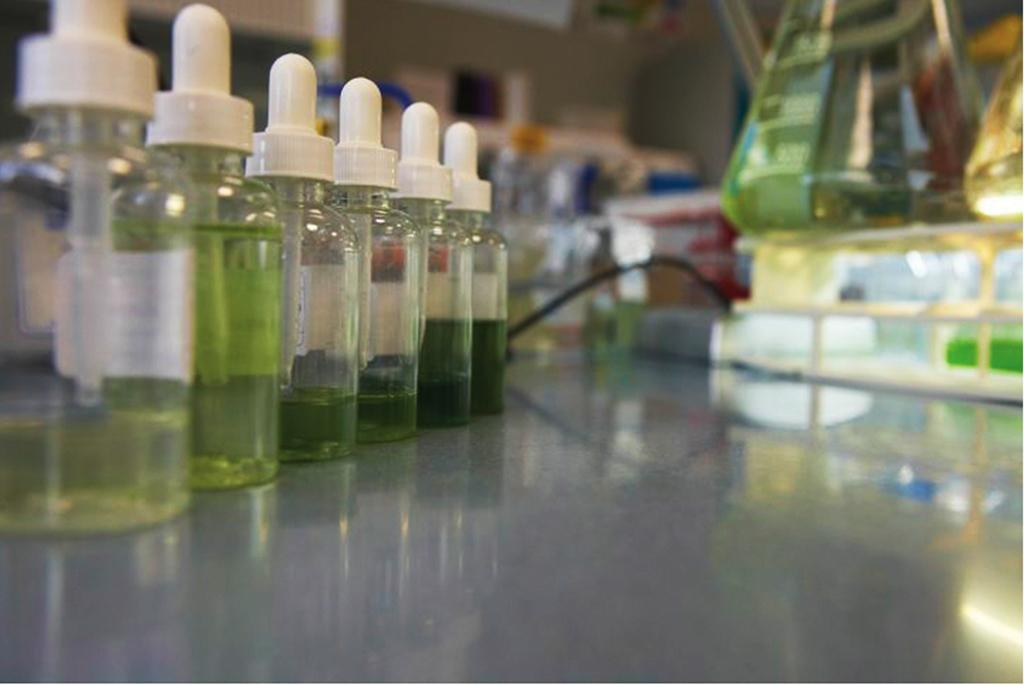What piece of furniture is present in the image? There is a table in the image. What objects are on the table? There are bottles on the table. What is the status of the bottle caps? The bottle caps are closed. How many dimes can be seen on the table in the image? There are no dimes present in the image. Can you describe the fairies that are jumping around the bottles in the image? There are no fairies present in the image. 